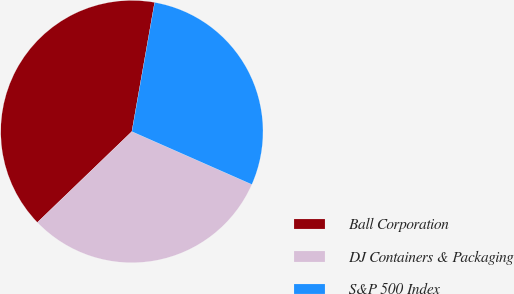Convert chart to OTSL. <chart><loc_0><loc_0><loc_500><loc_500><pie_chart><fcel>Ball Corporation<fcel>DJ Containers & Packaging<fcel>S&P 500 Index<nl><fcel>39.97%<fcel>31.2%<fcel>28.83%<nl></chart> 